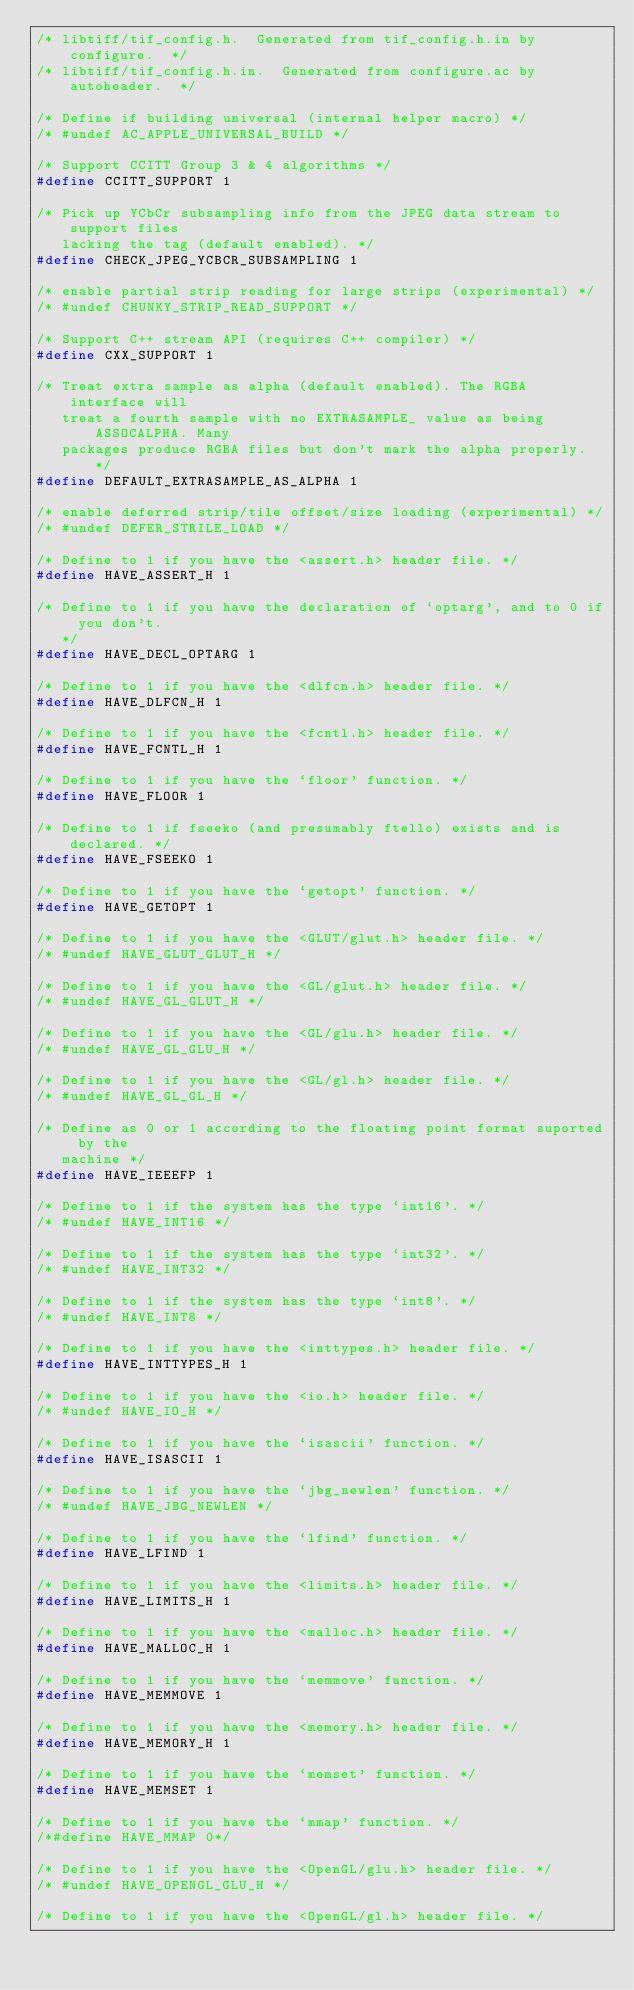Convert code to text. <code><loc_0><loc_0><loc_500><loc_500><_C_>/* libtiff/tif_config.h.  Generated from tif_config.h.in by configure.  */
/* libtiff/tif_config.h.in.  Generated from configure.ac by autoheader.  */

/* Define if building universal (internal helper macro) */
/* #undef AC_APPLE_UNIVERSAL_BUILD */

/* Support CCITT Group 3 & 4 algorithms */
#define CCITT_SUPPORT 1

/* Pick up YCbCr subsampling info from the JPEG data stream to support files
   lacking the tag (default enabled). */
#define CHECK_JPEG_YCBCR_SUBSAMPLING 1

/* enable partial strip reading for large strips (experimental) */
/* #undef CHUNKY_STRIP_READ_SUPPORT */

/* Support C++ stream API (requires C++ compiler) */
#define CXX_SUPPORT 1

/* Treat extra sample as alpha (default enabled). The RGBA interface will
   treat a fourth sample with no EXTRASAMPLE_ value as being ASSOCALPHA. Many
   packages produce RGBA files but don't mark the alpha properly. */
#define DEFAULT_EXTRASAMPLE_AS_ALPHA 1

/* enable deferred strip/tile offset/size loading (experimental) */
/* #undef DEFER_STRILE_LOAD */

/* Define to 1 if you have the <assert.h> header file. */
#define HAVE_ASSERT_H 1

/* Define to 1 if you have the declaration of `optarg', and to 0 if you don't.
   */
#define HAVE_DECL_OPTARG 1

/* Define to 1 if you have the <dlfcn.h> header file. */
#define HAVE_DLFCN_H 1

/* Define to 1 if you have the <fcntl.h> header file. */
#define HAVE_FCNTL_H 1

/* Define to 1 if you have the `floor' function. */
#define HAVE_FLOOR 1

/* Define to 1 if fseeko (and presumably ftello) exists and is declared. */
#define HAVE_FSEEKO 1

/* Define to 1 if you have the `getopt' function. */
#define HAVE_GETOPT 1

/* Define to 1 if you have the <GLUT/glut.h> header file. */
/* #undef HAVE_GLUT_GLUT_H */

/* Define to 1 if you have the <GL/glut.h> header file. */
/* #undef HAVE_GL_GLUT_H */

/* Define to 1 if you have the <GL/glu.h> header file. */
/* #undef HAVE_GL_GLU_H */

/* Define to 1 if you have the <GL/gl.h> header file. */
/* #undef HAVE_GL_GL_H */

/* Define as 0 or 1 according to the floating point format suported by the
   machine */
#define HAVE_IEEEFP 1

/* Define to 1 if the system has the type `int16'. */
/* #undef HAVE_INT16 */

/* Define to 1 if the system has the type `int32'. */
/* #undef HAVE_INT32 */

/* Define to 1 if the system has the type `int8'. */
/* #undef HAVE_INT8 */

/* Define to 1 if you have the <inttypes.h> header file. */
#define HAVE_INTTYPES_H 1

/* Define to 1 if you have the <io.h> header file. */
/* #undef HAVE_IO_H */

/* Define to 1 if you have the `isascii' function. */
#define HAVE_ISASCII 1

/* Define to 1 if you have the `jbg_newlen' function. */
/* #undef HAVE_JBG_NEWLEN */

/* Define to 1 if you have the `lfind' function. */
#define HAVE_LFIND 1

/* Define to 1 if you have the <limits.h> header file. */
#define HAVE_LIMITS_H 1

/* Define to 1 if you have the <malloc.h> header file. */
#define HAVE_MALLOC_H 1

/* Define to 1 if you have the `memmove' function. */
#define HAVE_MEMMOVE 1

/* Define to 1 if you have the <memory.h> header file. */
#define HAVE_MEMORY_H 1

/* Define to 1 if you have the `memset' function. */
#define HAVE_MEMSET 1

/* Define to 1 if you have the `mmap' function. */
/*#define HAVE_MMAP 0*/

/* Define to 1 if you have the <OpenGL/glu.h> header file. */
/* #undef HAVE_OPENGL_GLU_H */

/* Define to 1 if you have the <OpenGL/gl.h> header file. */</code> 